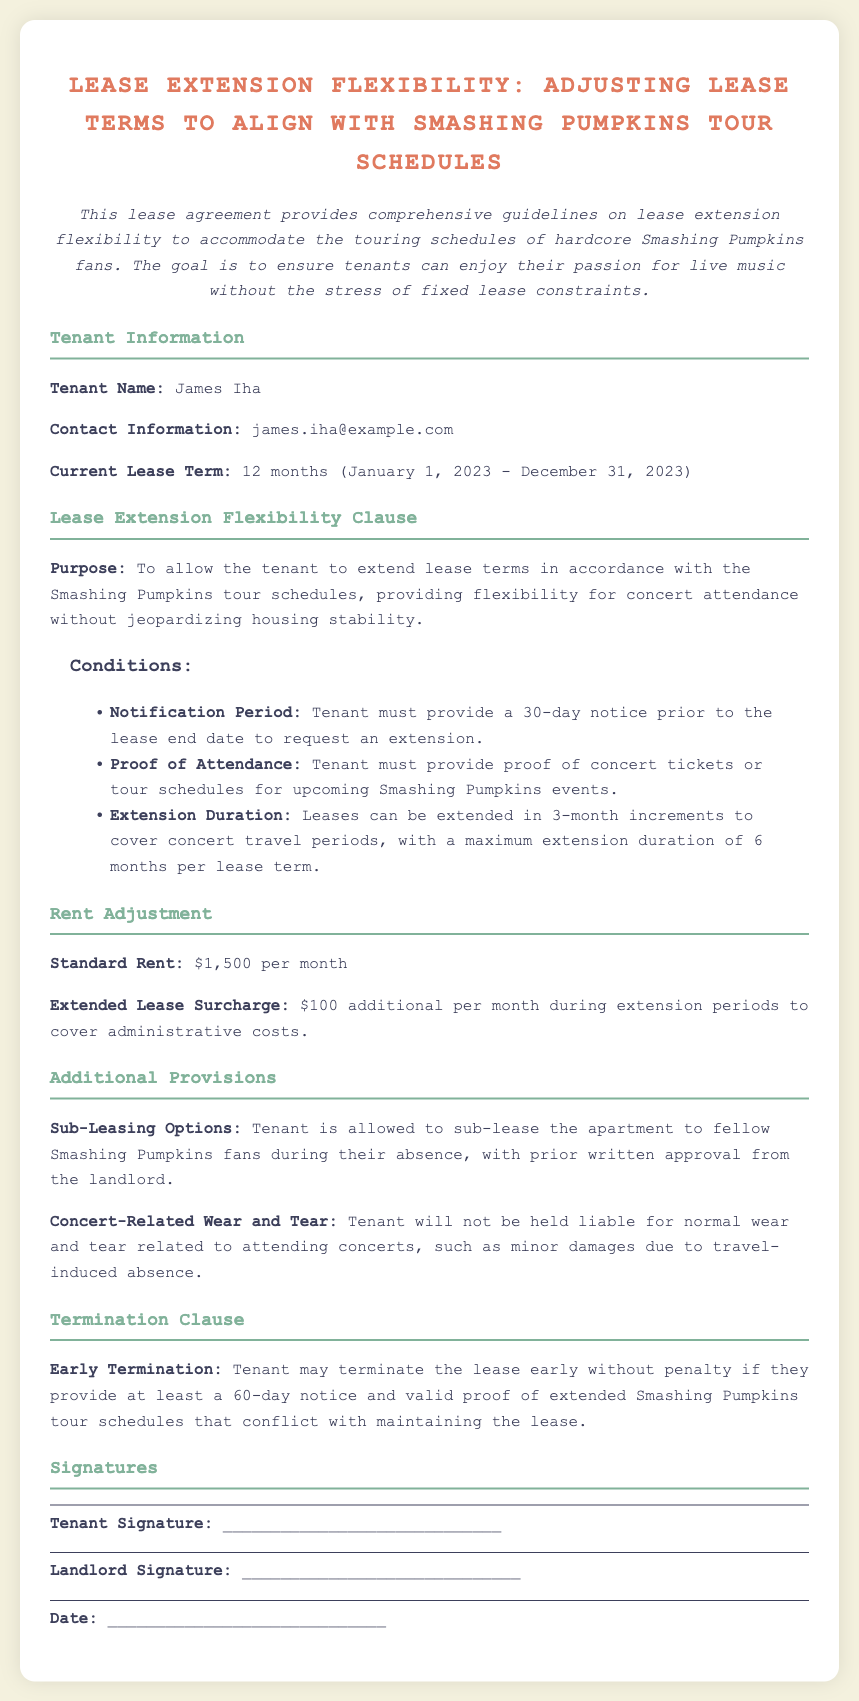What is the tenant's name? The tenant's name is mentioned in the "Tenant Information" section of the document.
Answer: James Iha What is the current lease term end date? The current lease term is outlined in the "Tenant Information" section, which specifies the duration.
Answer: December 31, 2023 What is the notification period for requesting an extension? The "Lease Extension Flexibility Clause" states the requirement for notification to request an extension.
Answer: 30-day notice How long can leases be extended at maximum? The "Lease Extension Flexibility Clause" details the maximum duration for lease extensions.
Answer: 6 months What is the standard rent amount? The "Rent Adjustment" section provides the standard rent amount for the lease.
Answer: $1,500 per month What additional amount is charged during extension periods? The "Rent Adjustment" section states the surcharge applicable during lease extensions.
Answer: $100 additional What is required for early termination of the lease? The "Termination Clause" describes the conditions necessary for early termination without penalty.
Answer: 60-day notice Can the tenant sub-lease the apartment? The "Additional Provisions" section discusses the option for sub-leasing the apartment.
Answer: Yes What proof is required for requesting an extension? The "Lease Extension Flexibility Clause" specifies what proof the tenant must provide for extensions.
Answer: Proof of concert tickets 